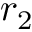<formula> <loc_0><loc_0><loc_500><loc_500>r _ { 2 }</formula> 